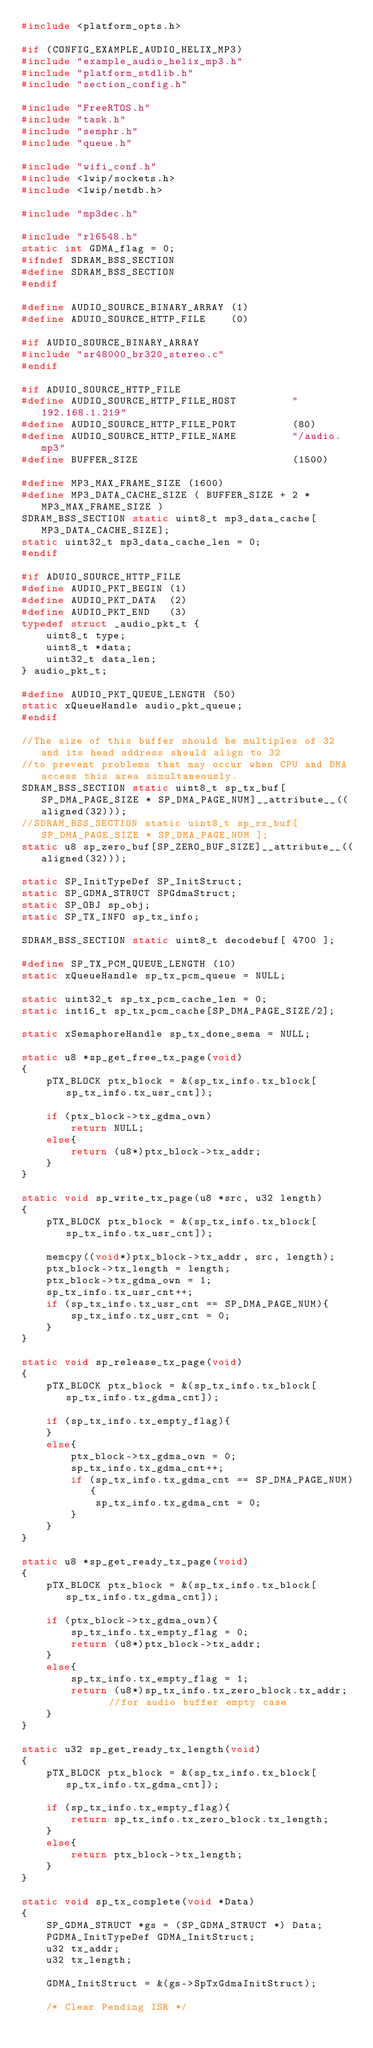Convert code to text. <code><loc_0><loc_0><loc_500><loc_500><_C_>#include <platform_opts.h>

#if (CONFIG_EXAMPLE_AUDIO_HELIX_MP3)
#include "example_audio_helix_mp3.h"
#include "platform_stdlib.h"
#include "section_config.h"

#include "FreeRTOS.h"
#include "task.h"
#include "semphr.h"
#include "queue.h"

#include "wifi_conf.h"
#include <lwip/sockets.h>
#include <lwip/netdb.h>

#include "mp3dec.h"

#include "rl6548.h"
static int GDMA_flag = 0; 
#ifndef SDRAM_BSS_SECTION
#define SDRAM_BSS_SECTION                        
#endif

#define AUDIO_SOURCE_BINARY_ARRAY (1)
#define ADUIO_SOURCE_HTTP_FILE    (0)

#if AUDIO_SOURCE_BINARY_ARRAY
#include "sr48000_br320_stereo.c"
#endif

#if ADUIO_SOURCE_HTTP_FILE
#define AUDIO_SOURCE_HTTP_FILE_HOST         "192.168.1.219"
#define AUDIO_SOURCE_HTTP_FILE_PORT         (80)
#define AUDIO_SOURCE_HTTP_FILE_NAME         "/audio.mp3"
#define BUFFER_SIZE                         (1500)

#define MP3_MAX_FRAME_SIZE (1600)
#define MP3_DATA_CACHE_SIZE ( BUFFER_SIZE + 2 * MP3_MAX_FRAME_SIZE )
SDRAM_BSS_SECTION static uint8_t mp3_data_cache[MP3_DATA_CACHE_SIZE];
static uint32_t mp3_data_cache_len = 0;
#endif

#if ADUIO_SOURCE_HTTP_FILE
#define AUDIO_PKT_BEGIN (1)
#define AUDIO_PKT_DATA  (2)
#define AUDIO_PKT_END   (3)
typedef struct _audio_pkt_t {
    uint8_t type;
    uint8_t *data;
    uint32_t data_len;
} audio_pkt_t;

#define AUDIO_PKT_QUEUE_LENGTH (50)
static xQueueHandle audio_pkt_queue;
#endif

//The size of this buffer should be multiples of 32 and its head address should align to 32 
//to prevent problems that may occur when CPU and DMA access this area simultaneously. 
SDRAM_BSS_SECTION static uint8_t sp_tx_buf[SP_DMA_PAGE_SIZE * SP_DMA_PAGE_NUM]__attribute__((aligned(32)));
//SDRAM_BSS_SECTION static uint8_t sp_rx_buf[ SP_DMA_PAGE_SIZE * SP_DMA_PAGE_NUM ];
static u8 sp_zero_buf[SP_ZERO_BUF_SIZE]__attribute__((aligned(32)));

static SP_InitTypeDef SP_InitStruct;
static SP_GDMA_STRUCT SPGdmaStruct;
static SP_OBJ sp_obj;
static SP_TX_INFO sp_tx_info;

SDRAM_BSS_SECTION static uint8_t decodebuf[ 4700 ];

#define SP_TX_PCM_QUEUE_LENGTH (10)
static xQueueHandle sp_tx_pcm_queue = NULL;

static uint32_t sp_tx_pcm_cache_len = 0;
static int16_t sp_tx_pcm_cache[SP_DMA_PAGE_SIZE/2];

static xSemaphoreHandle sp_tx_done_sema = NULL;

static u8 *sp_get_free_tx_page(void)
{
	pTX_BLOCK ptx_block = &(sp_tx_info.tx_block[sp_tx_info.tx_usr_cnt]);
	
	if (ptx_block->tx_gdma_own)
		return NULL;
	else{
		return (u8*)ptx_block->tx_addr;
	}	
}

static void sp_write_tx_page(u8 *src, u32 length)
{
	pTX_BLOCK ptx_block = &(sp_tx_info.tx_block[sp_tx_info.tx_usr_cnt]);
	
	memcpy((void*)ptx_block->tx_addr, src, length);
	ptx_block->tx_length = length;
	ptx_block->tx_gdma_own = 1;
	sp_tx_info.tx_usr_cnt++;
	if (sp_tx_info.tx_usr_cnt == SP_DMA_PAGE_NUM){
		sp_tx_info.tx_usr_cnt = 0;
	}
}

static void sp_release_tx_page(void)
{
	pTX_BLOCK ptx_block = &(sp_tx_info.tx_block[sp_tx_info.tx_gdma_cnt]);
	
	if (sp_tx_info.tx_empty_flag){
	}
	else{
		ptx_block->tx_gdma_own = 0;
		sp_tx_info.tx_gdma_cnt++;
		if (sp_tx_info.tx_gdma_cnt == SP_DMA_PAGE_NUM){
			sp_tx_info.tx_gdma_cnt = 0;
		}
	}
}

static u8 *sp_get_ready_tx_page(void)
{
	pTX_BLOCK ptx_block = &(sp_tx_info.tx_block[sp_tx_info.tx_gdma_cnt]);
	
	if (ptx_block->tx_gdma_own){
		sp_tx_info.tx_empty_flag = 0;
		return (u8*)ptx_block->tx_addr;
	}
	else{
		sp_tx_info.tx_empty_flag = 1;
		return (u8*)sp_tx_info.tx_zero_block.tx_addr;	//for audio buffer empty case
	}
}

static u32 sp_get_ready_tx_length(void)
{
	pTX_BLOCK ptx_block = &(sp_tx_info.tx_block[sp_tx_info.tx_gdma_cnt]);

	if (sp_tx_info.tx_empty_flag){
		return sp_tx_info.tx_zero_block.tx_length;
	}
	else{
		return ptx_block->tx_length;
	}
}

static void sp_tx_complete(void *Data)
{
	SP_GDMA_STRUCT *gs = (SP_GDMA_STRUCT *) Data;
	PGDMA_InitTypeDef GDMA_InitStruct;
	u32 tx_addr;
	u32 tx_length;
	
	GDMA_InitStruct = &(gs->SpTxGdmaInitStruct);

	/* Clear Pending ISR */</code> 